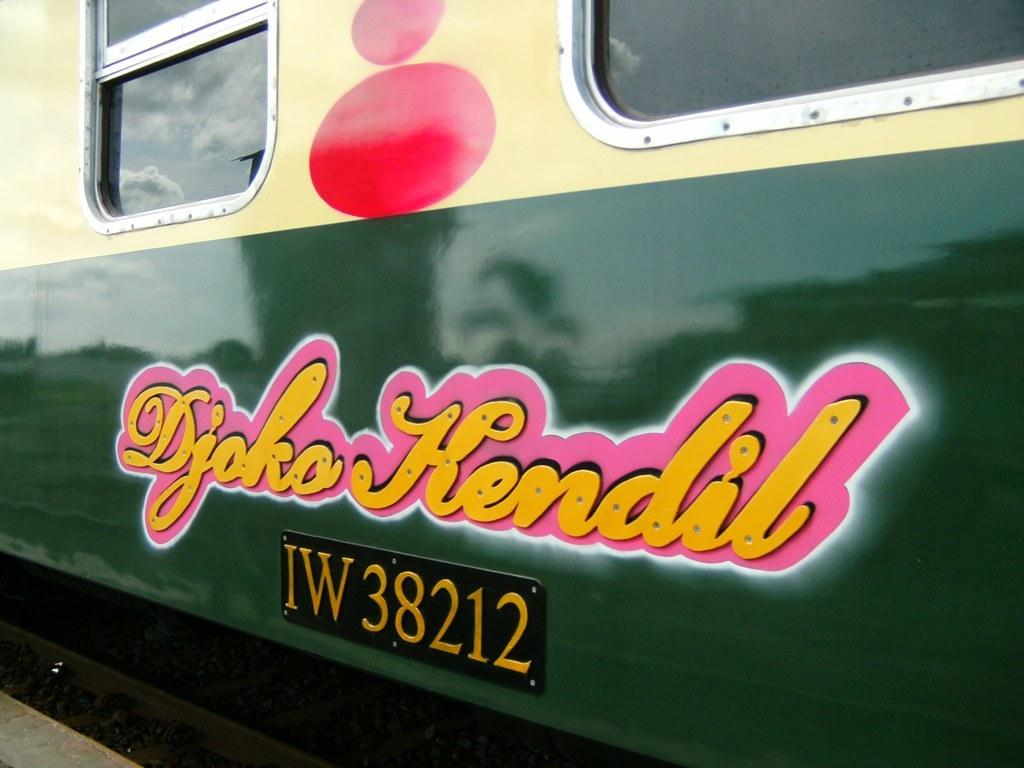What is the main subject of the image? The main subject of the image is a train. Is there any text or writing on the train? Yes, something is written on the train. What can be seen through the windows in the image? Windows are visible in the image, but it is not clear what can be seen through them. How many birds are sitting on the train's bulb in the image? There are no birds or bulbs present in the image; it features a train with writing on it and visible windows. 